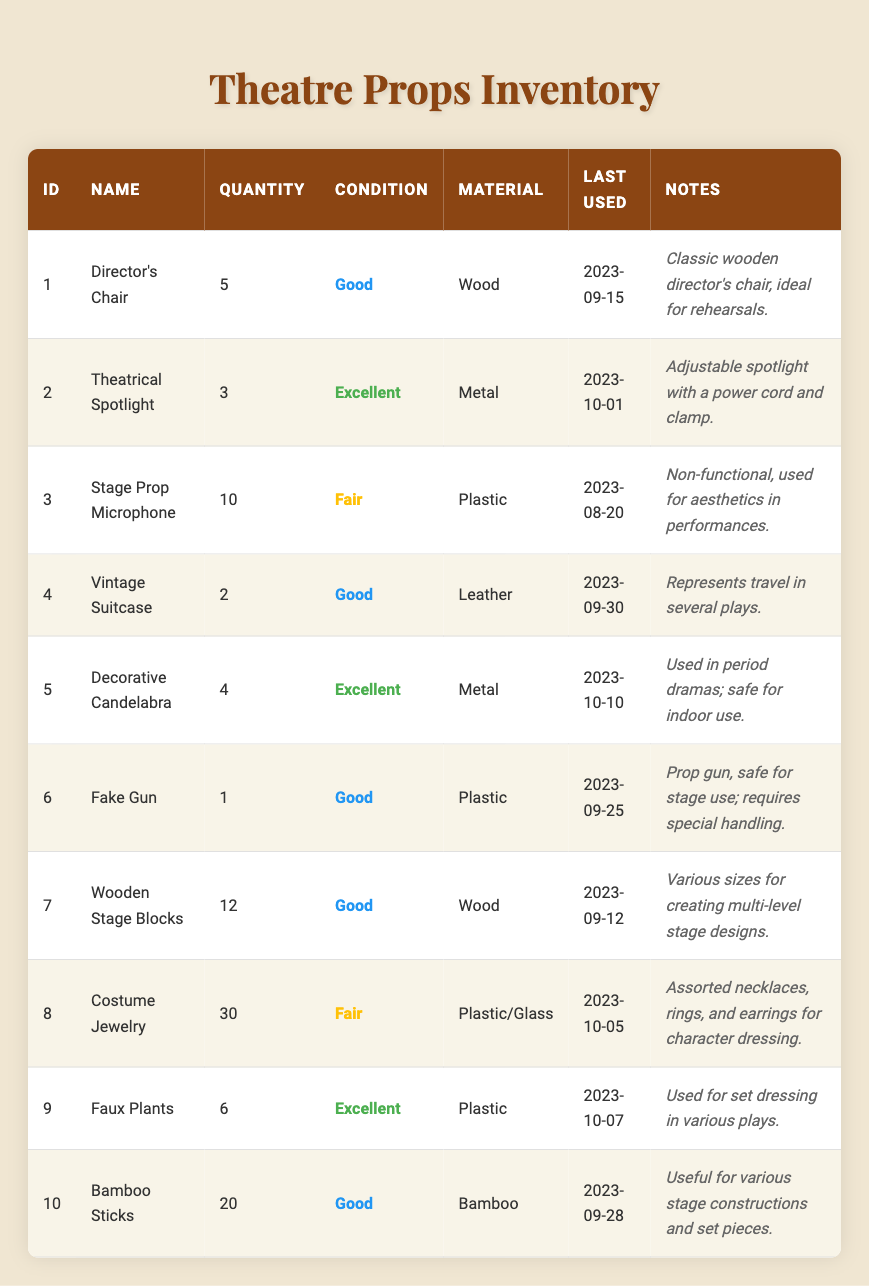What is the condition of the "Theatrical Spotlight"? The table lists the "Theatrical Spotlight" under the condition column, indicating it is in "Excellent" condition.
Answer: Excellent How many "Decorative Candelabras" are available? The table states there are 4 "Decorative Candelabras" in the quantity column.
Answer: 4 Which prop has the most quantity? By reviewing the quantity column, "Costume Jewelry" has the highest quantity at 30.
Answer: Costume Jewelry Is the "Stage Prop Microphone" in good condition? The table lists the condition of the "Stage Prop Microphone" as "Fair," which does not qualify as good condition.
Answer: No How many props are made of metal? Checking the material column, we count the "Theatrical Spotlight" (1), "Decorative Candelabra" (1), and "Faux Plants" (1), giving a total of 3 metal props.
Answer: 3 What is the average quantity of all props listed? To find the average, sum the quantities: (5 + 3 + 10 + 2 + 4 + 1 + 12 + 30 + 6 + 20) = 93. There are 10 props, so the average is 93/10 = 9.3.
Answer: 9.3 Which prop was last used on October 5th? Analyzing the last used column, "Costume Jewelry" is the only prop listed with that date.
Answer: Costume Jewelry Are there any props that are non-functional? The "Stage Prop Microphone" is non-functional as mentioned in the notes, making this fact true.
Answer: Yes Which prop has the most recent last-used date? Reviewing the last used dates, the "Decorative Candelabra" was last used on October 10, 2023, which is the most recent date.
Answer: Decorative Candelabra 